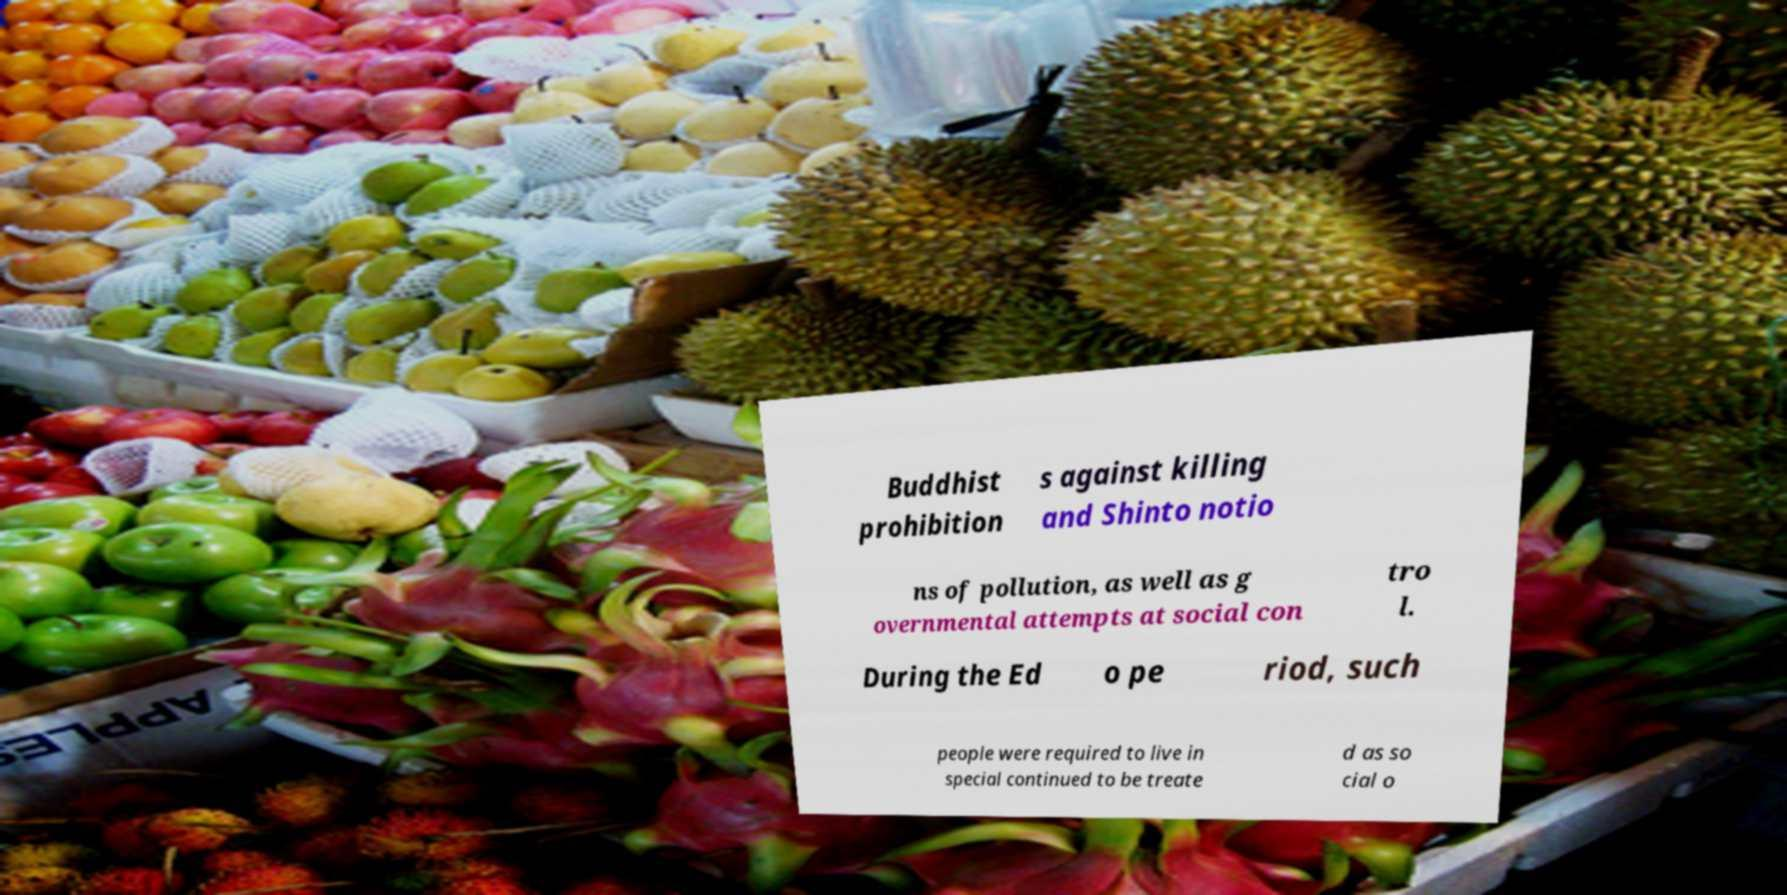For documentation purposes, I need the text within this image transcribed. Could you provide that? Buddhist prohibition s against killing and Shinto notio ns of pollution, as well as g overnmental attempts at social con tro l. During the Ed o pe riod, such people were required to live in special continued to be treate d as so cial o 